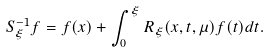<formula> <loc_0><loc_0><loc_500><loc_500>S _ { \xi } ^ { - 1 } f = f ( x ) + \int _ { 0 } ^ { \xi } R _ { \xi } ( x , t , \mu ) f ( t ) d t .</formula> 